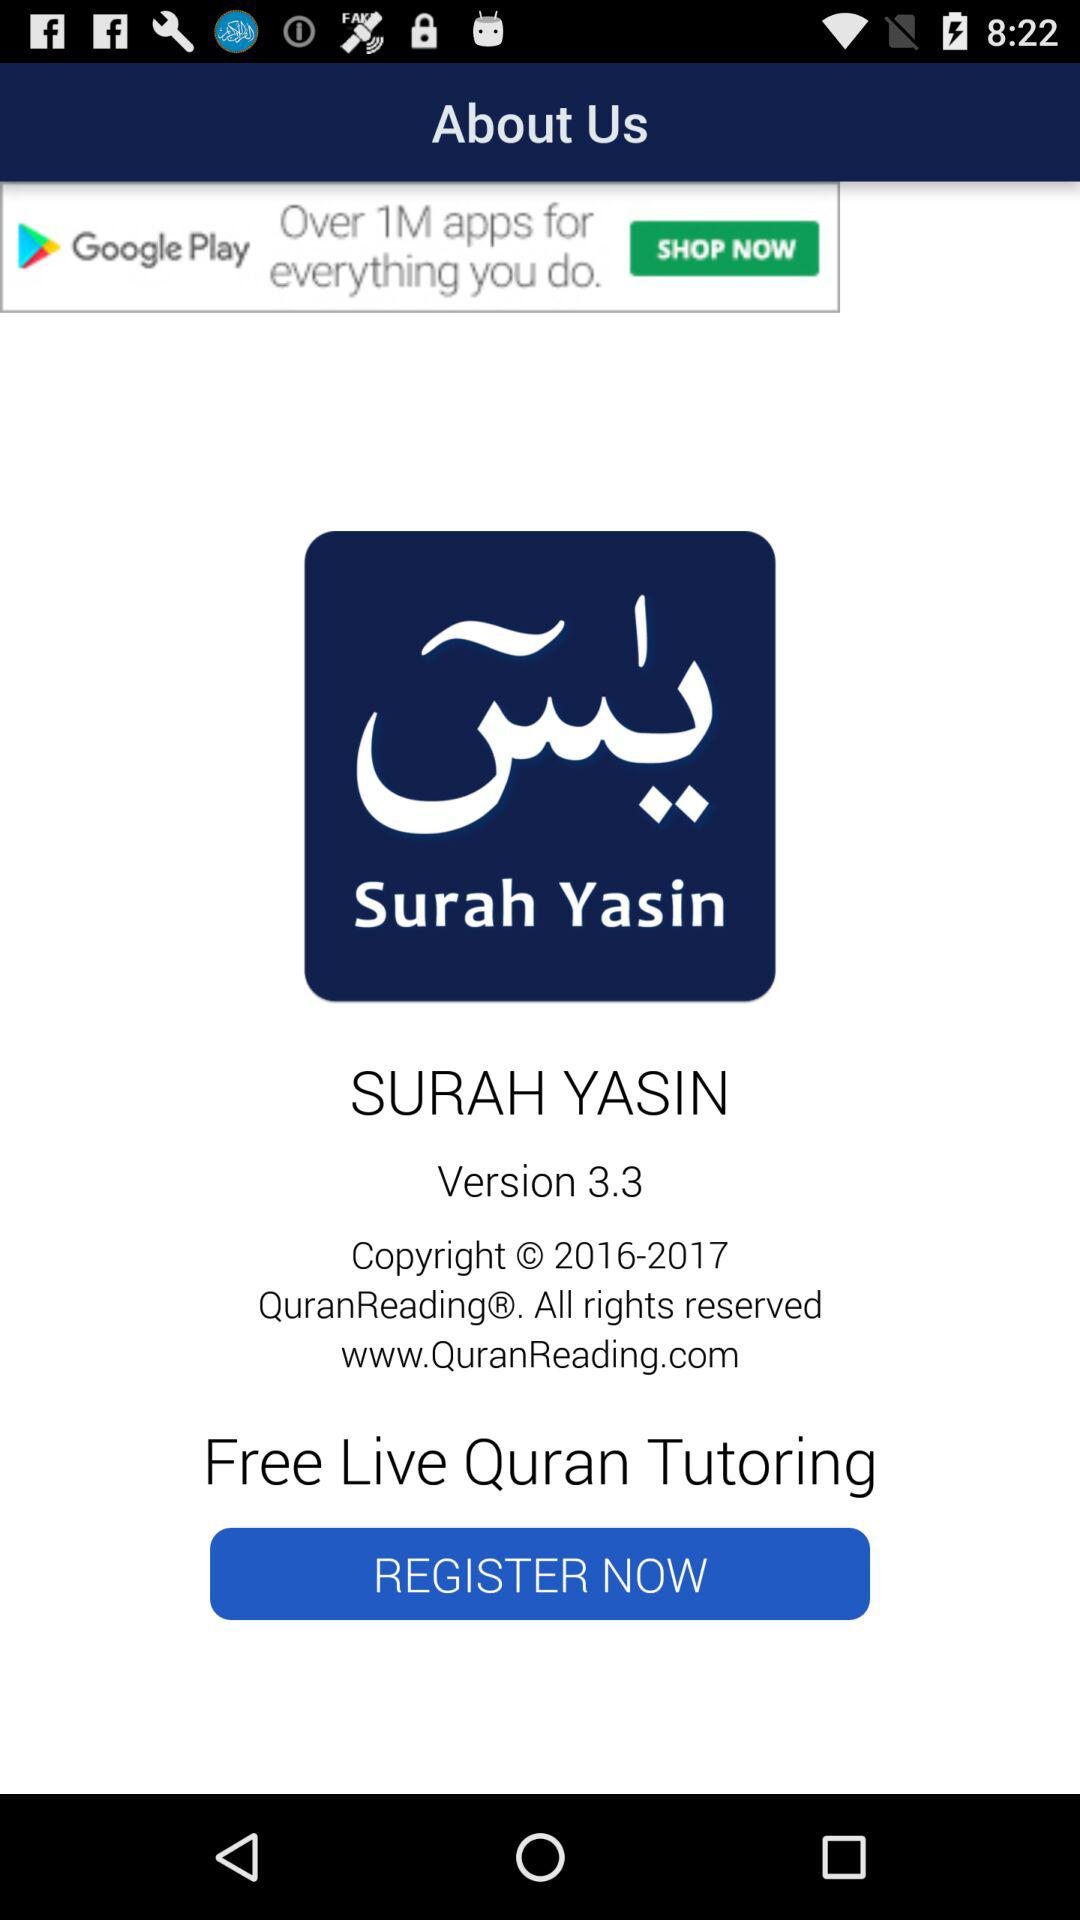What is the name? The name is Surah Yasin. 